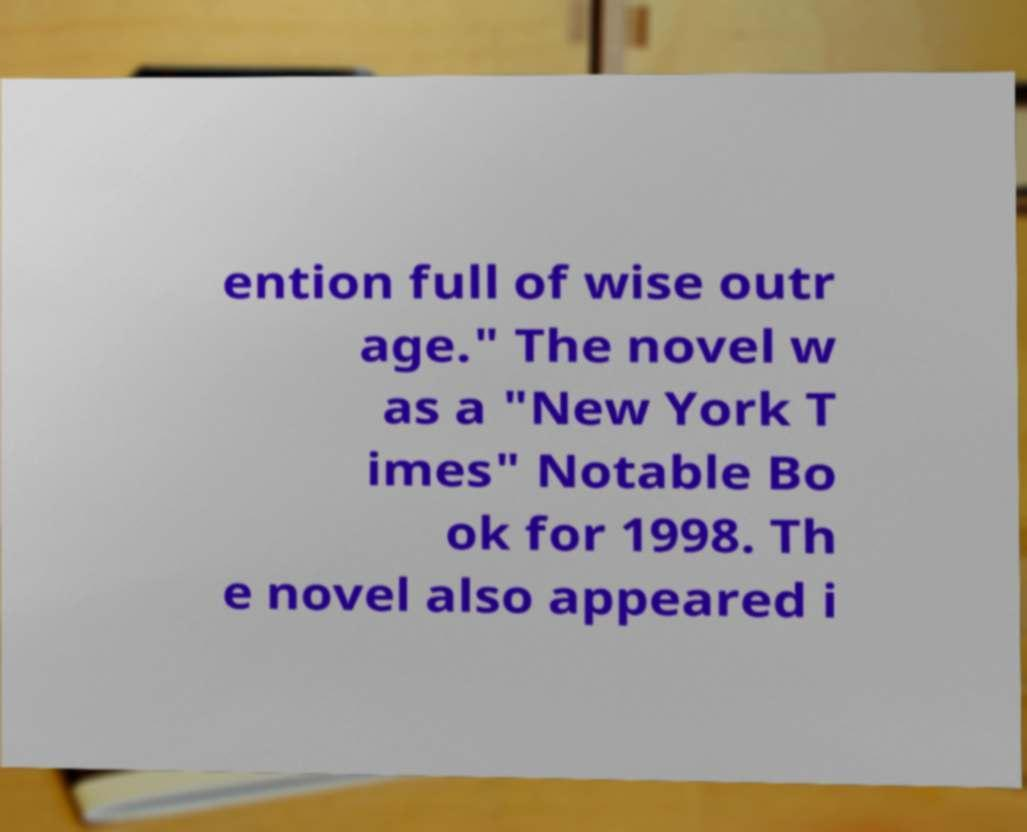For documentation purposes, I need the text within this image transcribed. Could you provide that? ention full of wise outr age." The novel w as a "New York T imes" Notable Bo ok for 1998. Th e novel also appeared i 